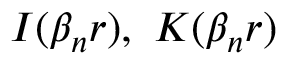<formula> <loc_0><loc_0><loc_500><loc_500>I ( \beta _ { n } r ) , \ K ( \beta _ { n } r )</formula> 